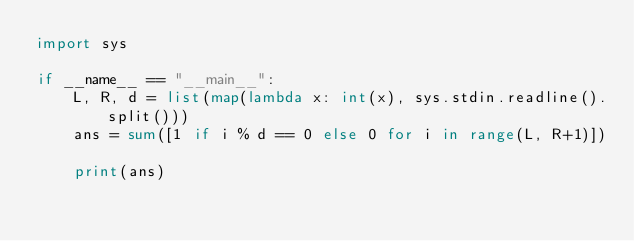<code> <loc_0><loc_0><loc_500><loc_500><_Python_>import sys

if __name__ == "__main__":
    L, R, d = list(map(lambda x: int(x), sys.stdin.readline().split()))
    ans = sum([1 if i % d == 0 else 0 for i in range(L, R+1)])
        
    print(ans)</code> 